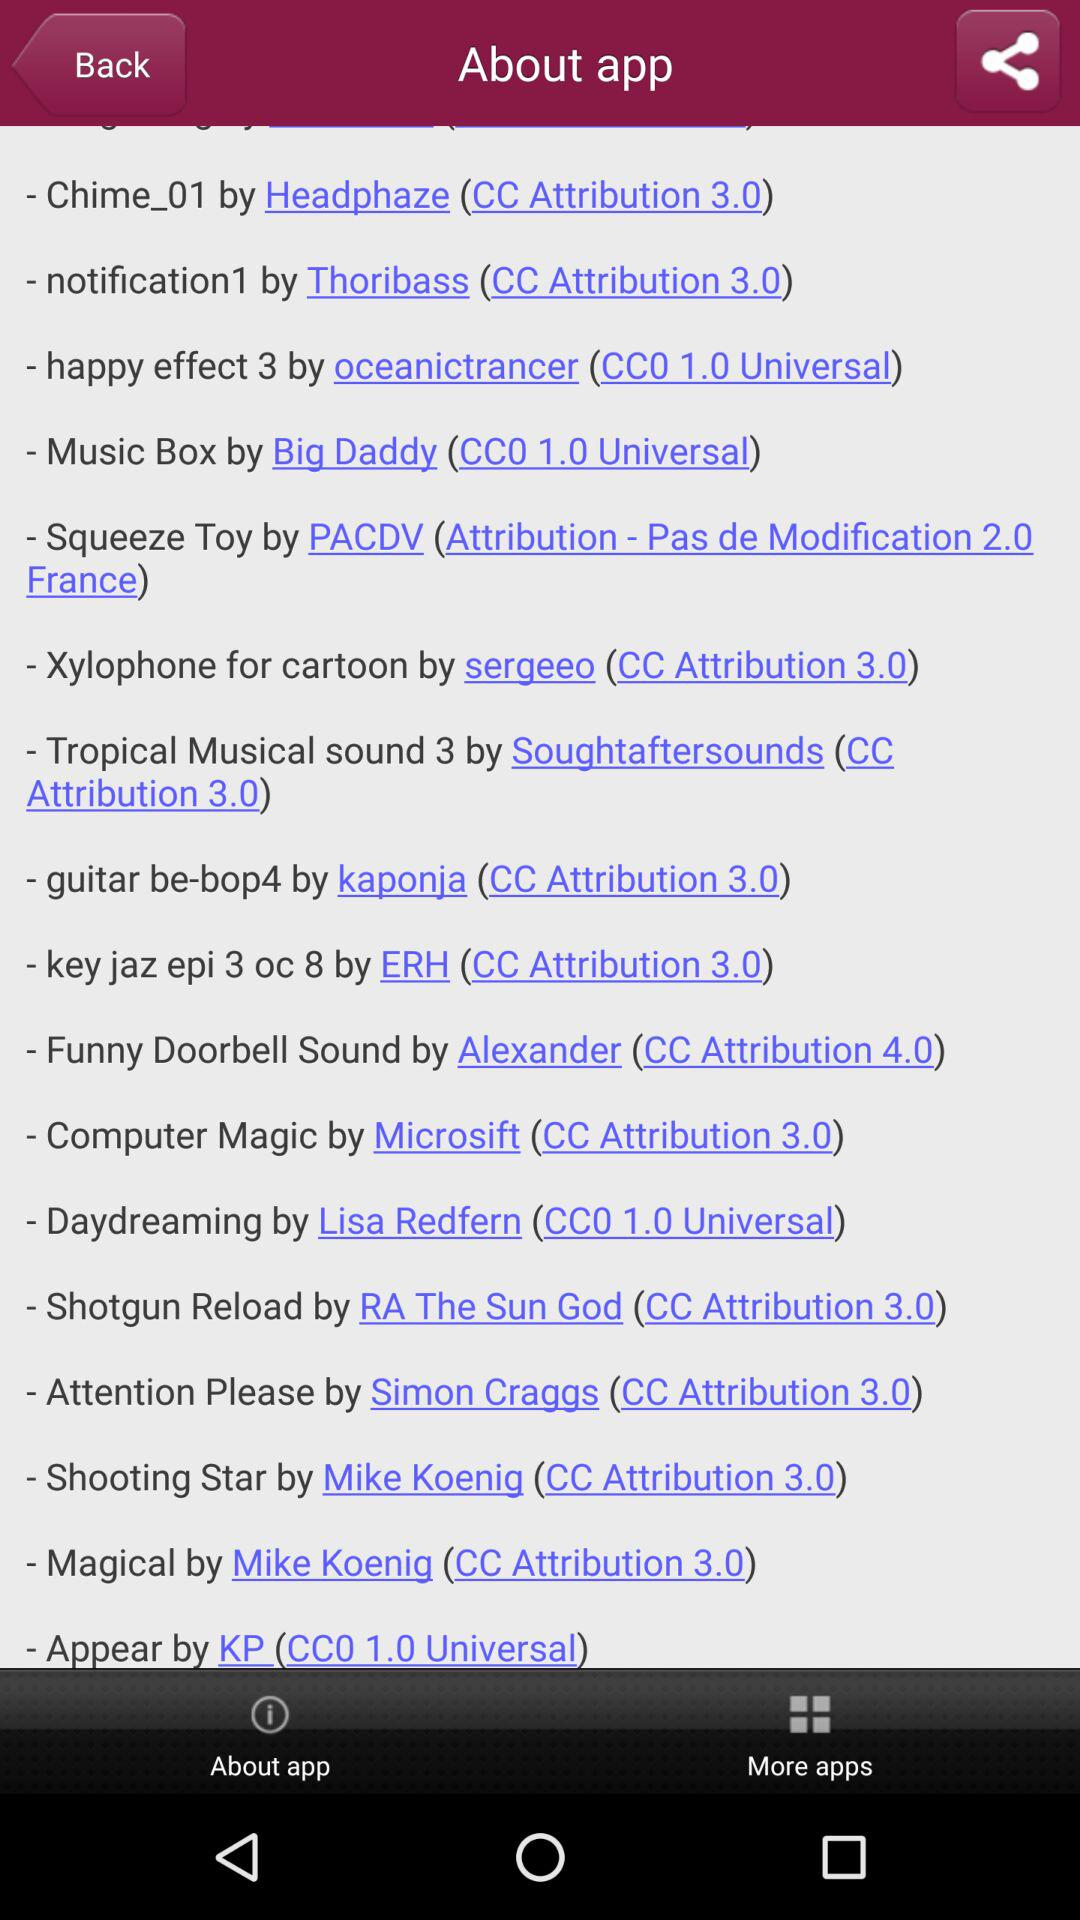Who developed "notification1"? It is developed by Thoribass. 